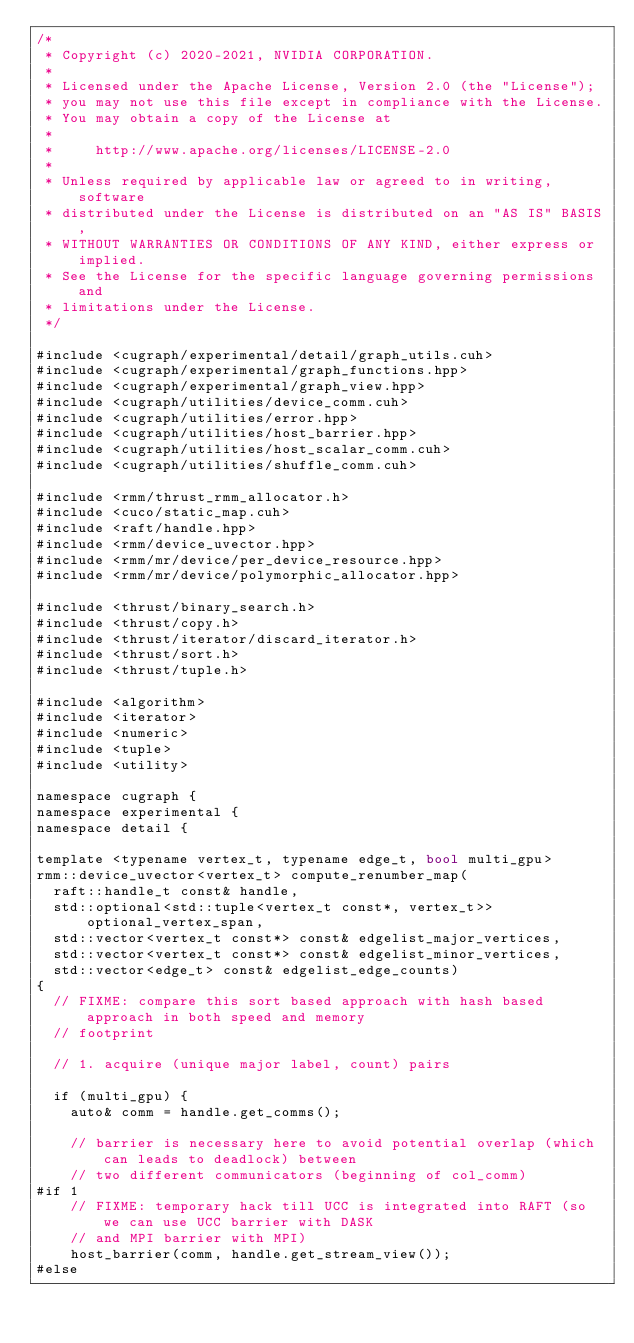<code> <loc_0><loc_0><loc_500><loc_500><_Cuda_>/*
 * Copyright (c) 2020-2021, NVIDIA CORPORATION.
 *
 * Licensed under the Apache License, Version 2.0 (the "License");
 * you may not use this file except in compliance with the License.
 * You may obtain a copy of the License at
 *
 *     http://www.apache.org/licenses/LICENSE-2.0
 *
 * Unless required by applicable law or agreed to in writing, software
 * distributed under the License is distributed on an "AS IS" BASIS,
 * WITHOUT WARRANTIES OR CONDITIONS OF ANY KIND, either express or implied.
 * See the License for the specific language governing permissions and
 * limitations under the License.
 */

#include <cugraph/experimental/detail/graph_utils.cuh>
#include <cugraph/experimental/graph_functions.hpp>
#include <cugraph/experimental/graph_view.hpp>
#include <cugraph/utilities/device_comm.cuh>
#include <cugraph/utilities/error.hpp>
#include <cugraph/utilities/host_barrier.hpp>
#include <cugraph/utilities/host_scalar_comm.cuh>
#include <cugraph/utilities/shuffle_comm.cuh>

#include <rmm/thrust_rmm_allocator.h>
#include <cuco/static_map.cuh>
#include <raft/handle.hpp>
#include <rmm/device_uvector.hpp>
#include <rmm/mr/device/per_device_resource.hpp>
#include <rmm/mr/device/polymorphic_allocator.hpp>

#include <thrust/binary_search.h>
#include <thrust/copy.h>
#include <thrust/iterator/discard_iterator.h>
#include <thrust/sort.h>
#include <thrust/tuple.h>

#include <algorithm>
#include <iterator>
#include <numeric>
#include <tuple>
#include <utility>

namespace cugraph {
namespace experimental {
namespace detail {

template <typename vertex_t, typename edge_t, bool multi_gpu>
rmm::device_uvector<vertex_t> compute_renumber_map(
  raft::handle_t const& handle,
  std::optional<std::tuple<vertex_t const*, vertex_t>> optional_vertex_span,
  std::vector<vertex_t const*> const& edgelist_major_vertices,
  std::vector<vertex_t const*> const& edgelist_minor_vertices,
  std::vector<edge_t> const& edgelist_edge_counts)
{
  // FIXME: compare this sort based approach with hash based approach in both speed and memory
  // footprint

  // 1. acquire (unique major label, count) pairs

  if (multi_gpu) {
    auto& comm = handle.get_comms();

    // barrier is necessary here to avoid potential overlap (which can leads to deadlock) between
    // two different communicators (beginning of col_comm)
#if 1
    // FIXME: temporary hack till UCC is integrated into RAFT (so we can use UCC barrier with DASK
    // and MPI barrier with MPI)
    host_barrier(comm, handle.get_stream_view());
#else</code> 